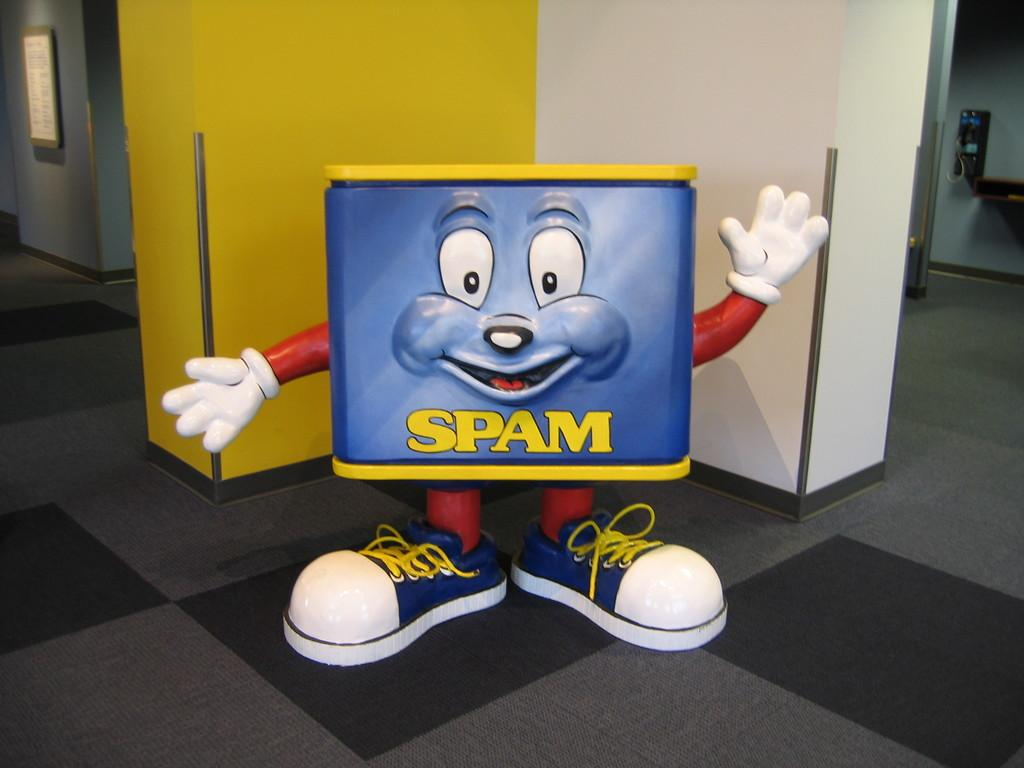What object is placed on the floor in the image? There is a toy on the floor in the image. What can be seen in the background of the image? In the background of the image, there is a frame, a telephone, a door, walls, and some objects. Can you describe the objects in the background of the image? Unfortunately, the provided facts do not give specific details about the objects in the background. How many distinct elements can be seen in the background of the image? There are at least six distinct elements in the background of the image: a frame, a telephone, a door, walls, and some objects. What type of noise is being made by the quartz in the image? There is no quartz present in the image, so it is not possible to determine if any noise is being made by it. 